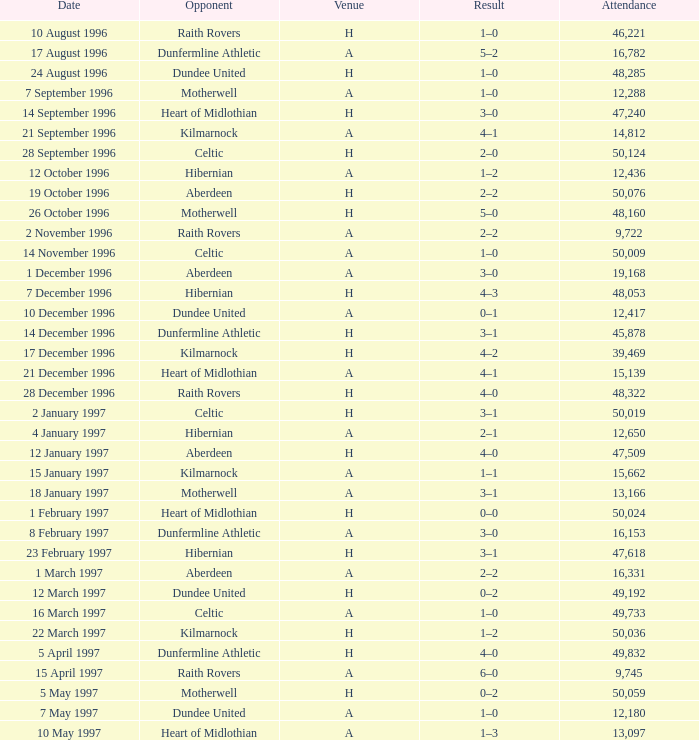When did venue A have an attendance larger than 48,053, and a result of 1–0? 14 November 1996, 16 March 1997. 